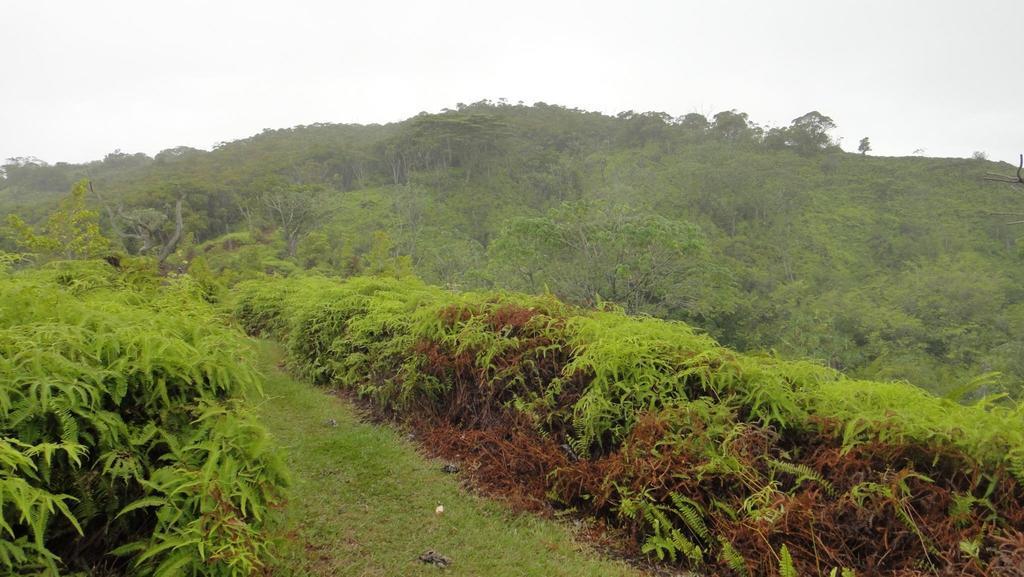In one or two sentences, can you explain what this image depicts? In this image we can see some plants, trees and grass on the ground, in the background, we can see the sky. 